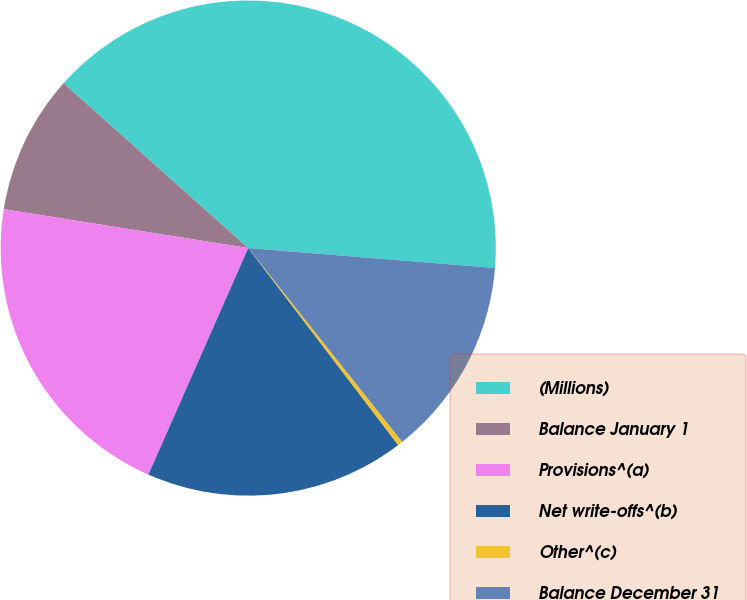Convert chart. <chart><loc_0><loc_0><loc_500><loc_500><pie_chart><fcel>(Millions)<fcel>Balance January 1<fcel>Provisions^(a)<fcel>Net write-offs^(b)<fcel>Other^(c)<fcel>Balance December 31<nl><fcel>39.68%<fcel>9.09%<fcel>20.9%<fcel>16.96%<fcel>0.33%<fcel>13.03%<nl></chart> 